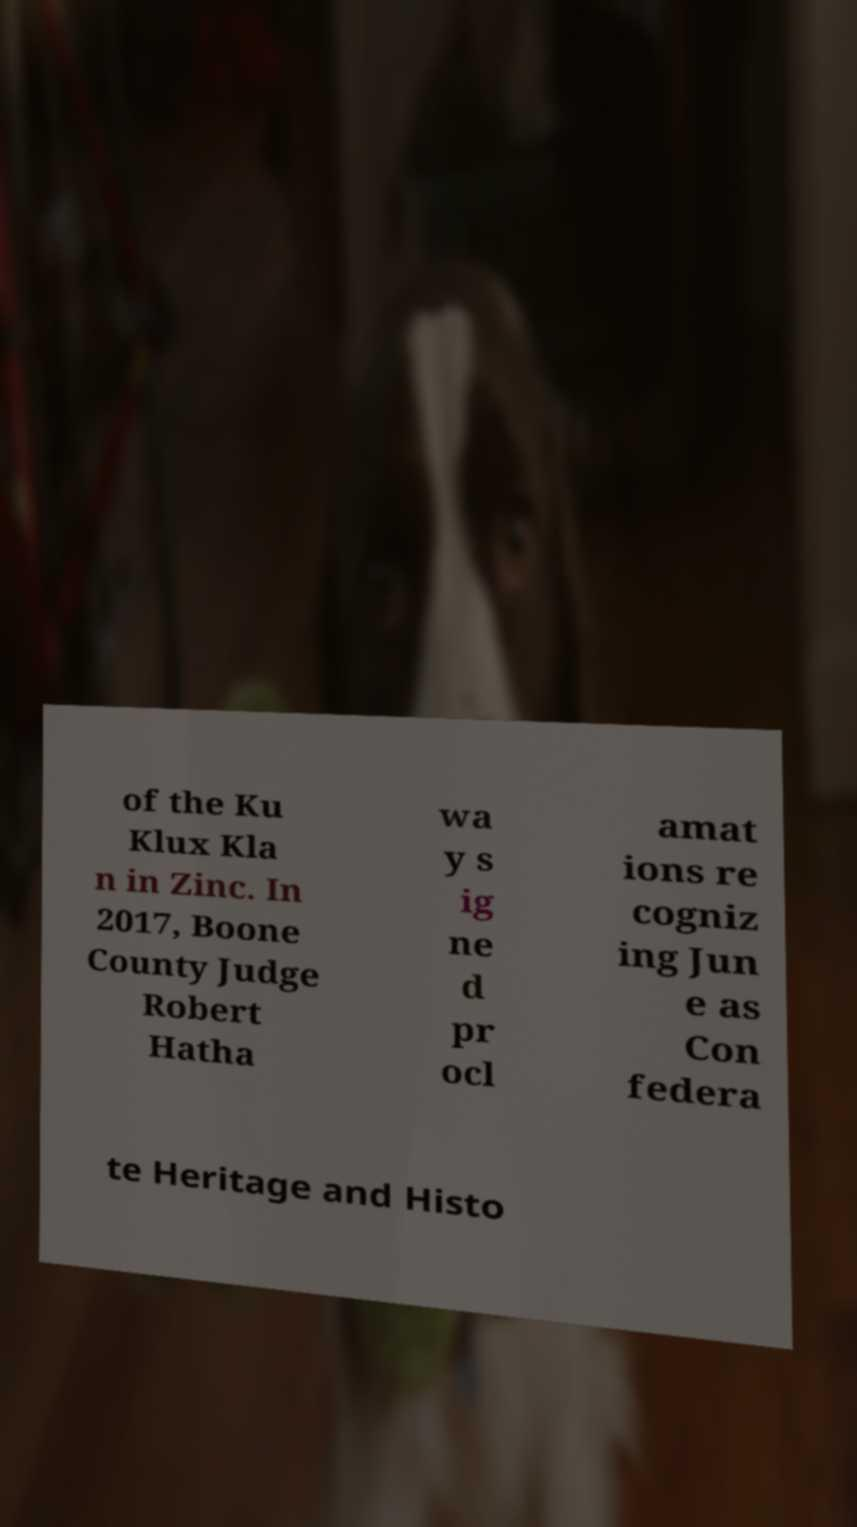Could you extract and type out the text from this image? of the Ku Klux Kla n in Zinc. In 2017, Boone County Judge Robert Hatha wa y s ig ne d pr ocl amat ions re cogniz ing Jun e as Con federa te Heritage and Histo 